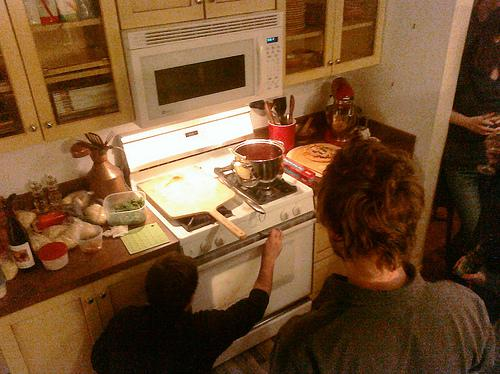Question: where in the home is this photo?
Choices:
A. Living room.
B. Bedroom.
C. Dining room.
D. Kitchen.
Answer with the letter. Answer: D Question: where is the microwave?
Choices:
A. Above the stove.
B. Next to the toaster.
C. To the left of the fridge.
D. Right of the sink.
Answer with the letter. Answer: A Question: where is this scene?
Choices:
A. In a backyard.
B. Inside a home.
C. In a forest.
D. On a beach.
Answer with the letter. Answer: B Question: what appliance is being used?
Choices:
A. Blender.
B. Microwave.
C. Dishwasher.
D. Oven.
Answer with the letter. Answer: D Question: where is the mixer?
Choices:
A. On the table.
B. In the cabinet.
C. On the counter.
D. In storage.
Answer with the letter. Answer: C Question: how many people are in the photo?
Choices:
A. Two.
B. One.
C. Three.
D. Four.
Answer with the letter. Answer: C 